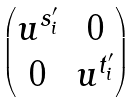Convert formula to latex. <formula><loc_0><loc_0><loc_500><loc_500>\begin{pmatrix} u ^ { s _ { i } ^ { \prime } } & 0 \\ 0 & u ^ { t _ { i } ^ { \prime } } \end{pmatrix}</formula> 